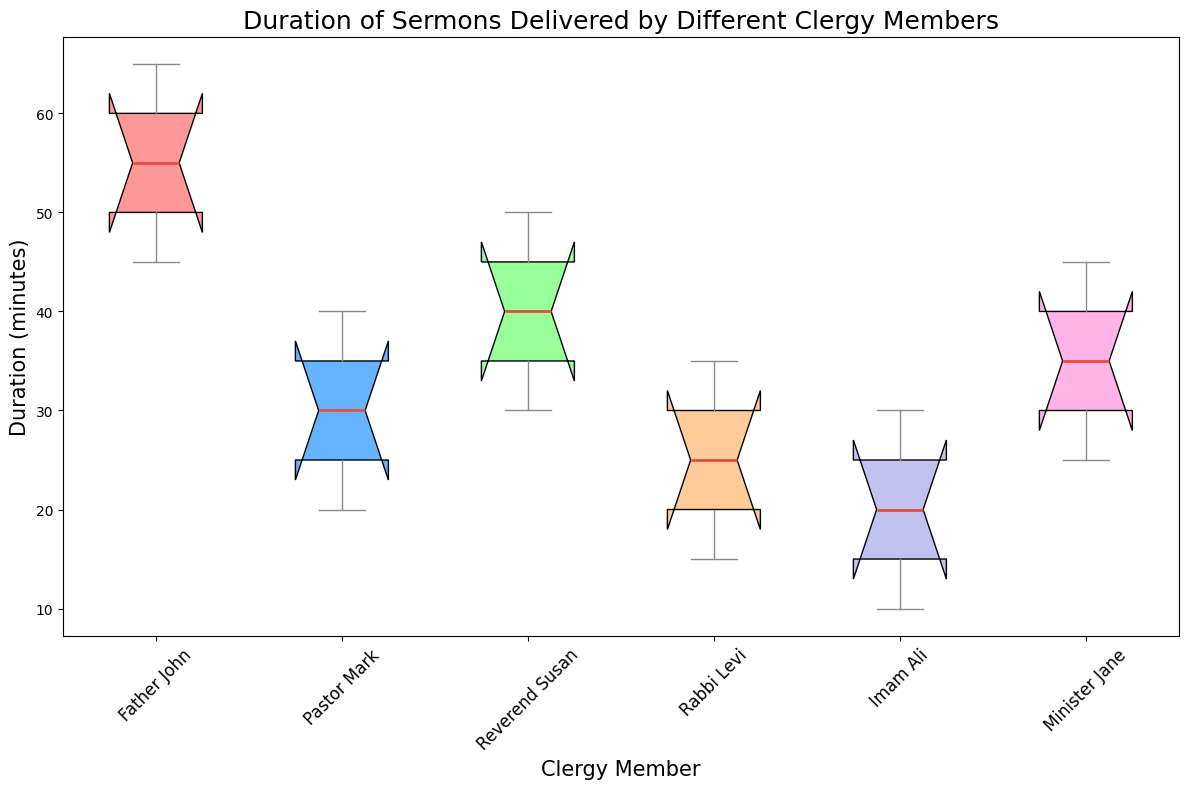What is the median duration of sermons delivered by Reverend Susan? First, identify Reverend Susan's data set, which is [30, 35, 40, 45, 50]. The median is the middle value when the numbers are listed in ascending order. The median value here is 40.
Answer: 40 Which clergy member delivers the shortest sermons on average? Calculate the average duration for each clergy member. Father John: (45+50+55+60+65)/5 = 55; Pastor Mark: (20+25+30+35+40)/5 = 30; Reverend Susan: (30+35+40+45+50)/5 = 40; Rabbi Levi: (15+20+25+30+35)/5 = 25; Imam Ali: (10+15+20+25+30)/5 = 20; Minister Jane: (25+30+35+40+45)/5 = 35. The shortest average sermon duration is delivered by Imam Ali.
Answer: Imam Ali Based on the box plot, which clergy member has the widest range of sermon durations? The range is determined by subtracting the minimum from the maximum value within the box plot. Father John: 65-45=20; Pastor Mark: 40-20=20; Reverend Susan: 50-30=20; Rabbi Levi: 35-15=20; Imam Ali: 30-10=20; Minister Jane: 45-25=20. Here, all clergy members have the same range.
Answer: All have the same range Which clergy members have a higher median sermon duration than Pastor Mark? From the box plot, identify the median values: Father John ~ 55, Pastor Mark ~ 30, Reverend Susan ~ 40, Rabbi Levi ~ 25, Imam Ali ~ 20, Minister Jane ~ 35. Compare these values. Clergy members with a higher median sermon duration than Pastor Mark are Reverend Susan, Minister Jane, and Father John.
Answer: Reverend Susan, Minister Jane, Father John What colors represent the boxes for Imam Ali and Reverend Susan? The box for Imam Ali is colored yellow, and the box for Reverend Susan is colored green.
Answer: yellow, green Which clergy member has the least variability in sermon durations based on the box plot? The variability can be inferred from the interquartile range (IQR), represented by the width of the box in the plot. The narrower the box, the less the variability. Among all clergy members, the narrowest variability box is observed for Reverend Susan.
Answer: Reverend Susan How does the median value of Minister Jane’s sermons compare to that of Father John's sermons? From the box plot, identify the median values: Minister Jane ~ 35, Father John ~ 55. Comparison shows that Father John's median sermon duration is greater than Minister Jane’s median sermon duration.
Answer: Father John’s median is greater What's the range of sermon durations delivered by Rabbi Levi? The range is calculated by subtracting the minimum value from the maximum value. Rabbi Levi’s durations: 15 to 35. Thus, the range is 35 - 15 = 20.
Answer: 20 